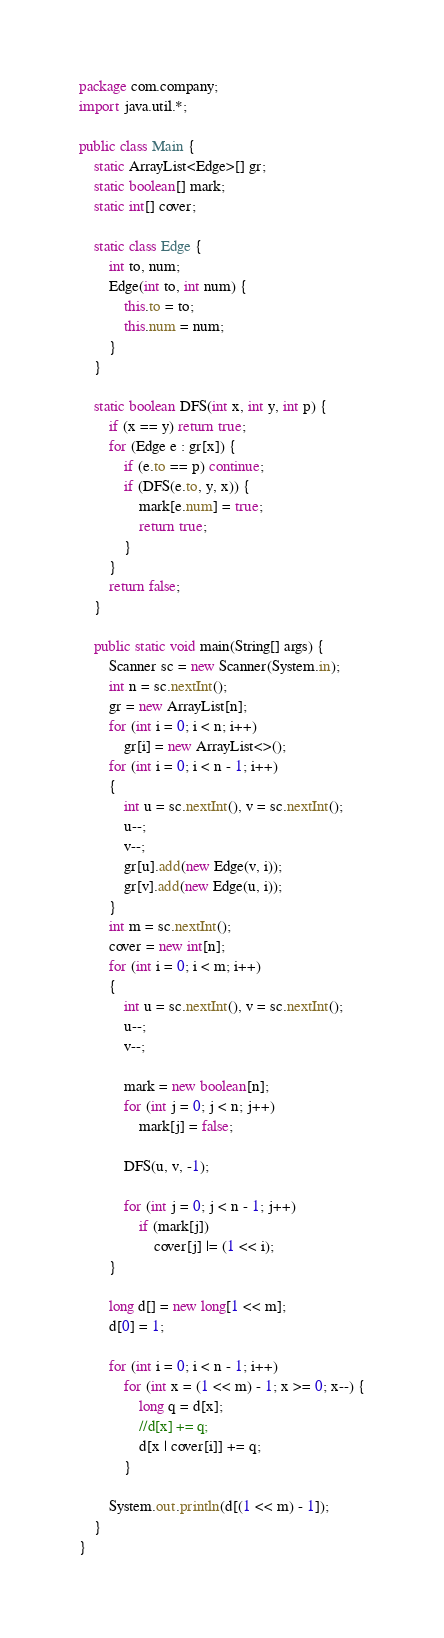<code> <loc_0><loc_0><loc_500><loc_500><_Java_>package com.company;
import java.util.*;

public class Main {
    static ArrayList<Edge>[] gr;
    static boolean[] mark;
    static int[] cover;

    static class Edge {
        int to, num;
        Edge(int to, int num) {
            this.to = to;
            this.num = num;
        }
    }

    static boolean DFS(int x, int y, int p) {
        if (x == y) return true;
        for (Edge e : gr[x]) {
            if (e.to == p) continue;
            if (DFS(e.to, y, x)) {
                mark[e.num] = true;
                return true;
            }
        }
        return false;
    }

    public static void main(String[] args) {
        Scanner sc = new Scanner(System.in);
        int n = sc.nextInt();
        gr = new ArrayList[n];
        for (int i = 0; i < n; i++)
            gr[i] = new ArrayList<>();
        for (int i = 0; i < n - 1; i++)
        {
            int u = sc.nextInt(), v = sc.nextInt();
            u--;
            v--;
            gr[u].add(new Edge(v, i));
            gr[v].add(new Edge(u, i));
        }
        int m = sc.nextInt();
        cover = new int[n];
        for (int i = 0; i < m; i++)
        {
            int u = sc.nextInt(), v = sc.nextInt();
            u--;
            v--;

            mark = new boolean[n];
            for (int j = 0; j < n; j++)
                mark[j] = false;

            DFS(u, v, -1);

            for (int j = 0; j < n - 1; j++)
                if (mark[j])
                    cover[j] |= (1 << i);
        }

        long d[] = new long[1 << m];
        d[0] = 1;

        for (int i = 0; i < n - 1; i++)
            for (int x = (1 << m) - 1; x >= 0; x--) {
                long q = d[x];
                //d[x] += q;
                d[x | cover[i]] += q;
            }

        System.out.println(d[(1 << m) - 1]);
    }
}
</code> 